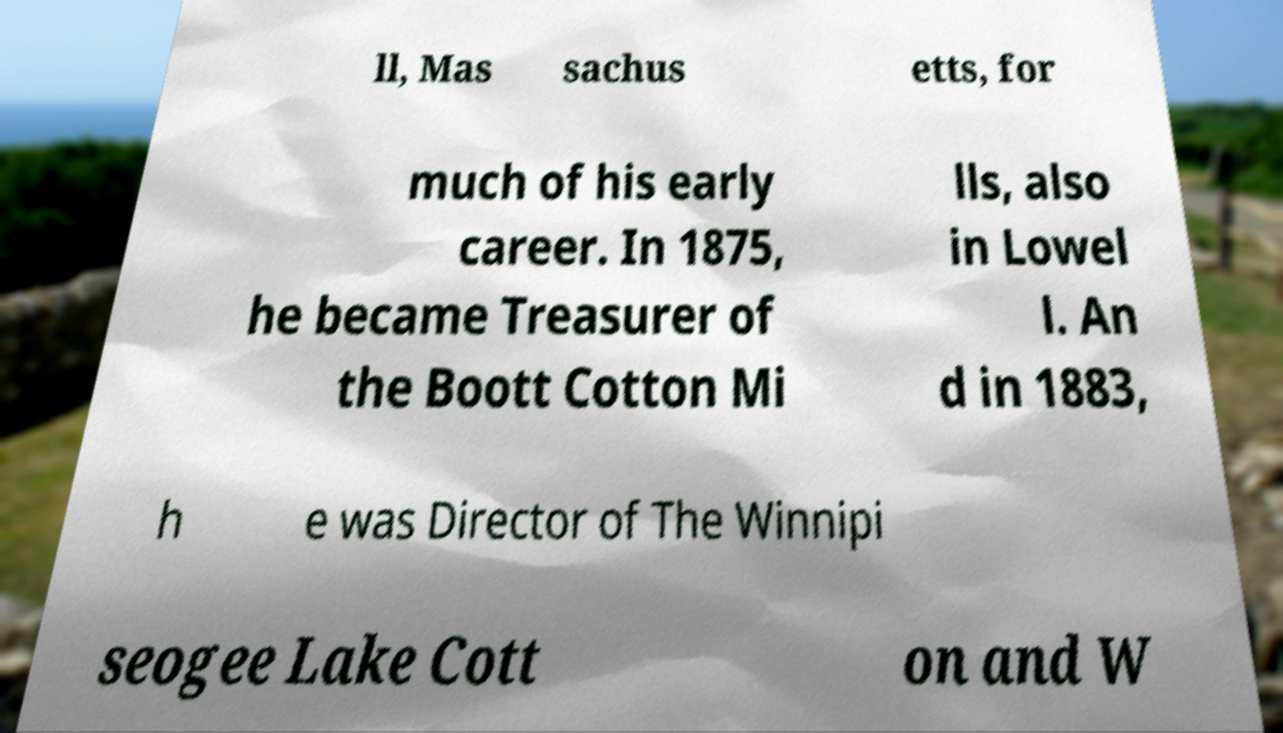Please read and relay the text visible in this image. What does it say? ll, Mas sachus etts, for much of his early career. In 1875, he became Treasurer of the Boott Cotton Mi lls, also in Lowel l. An d in 1883, h e was Director of The Winnipi seogee Lake Cott on and W 